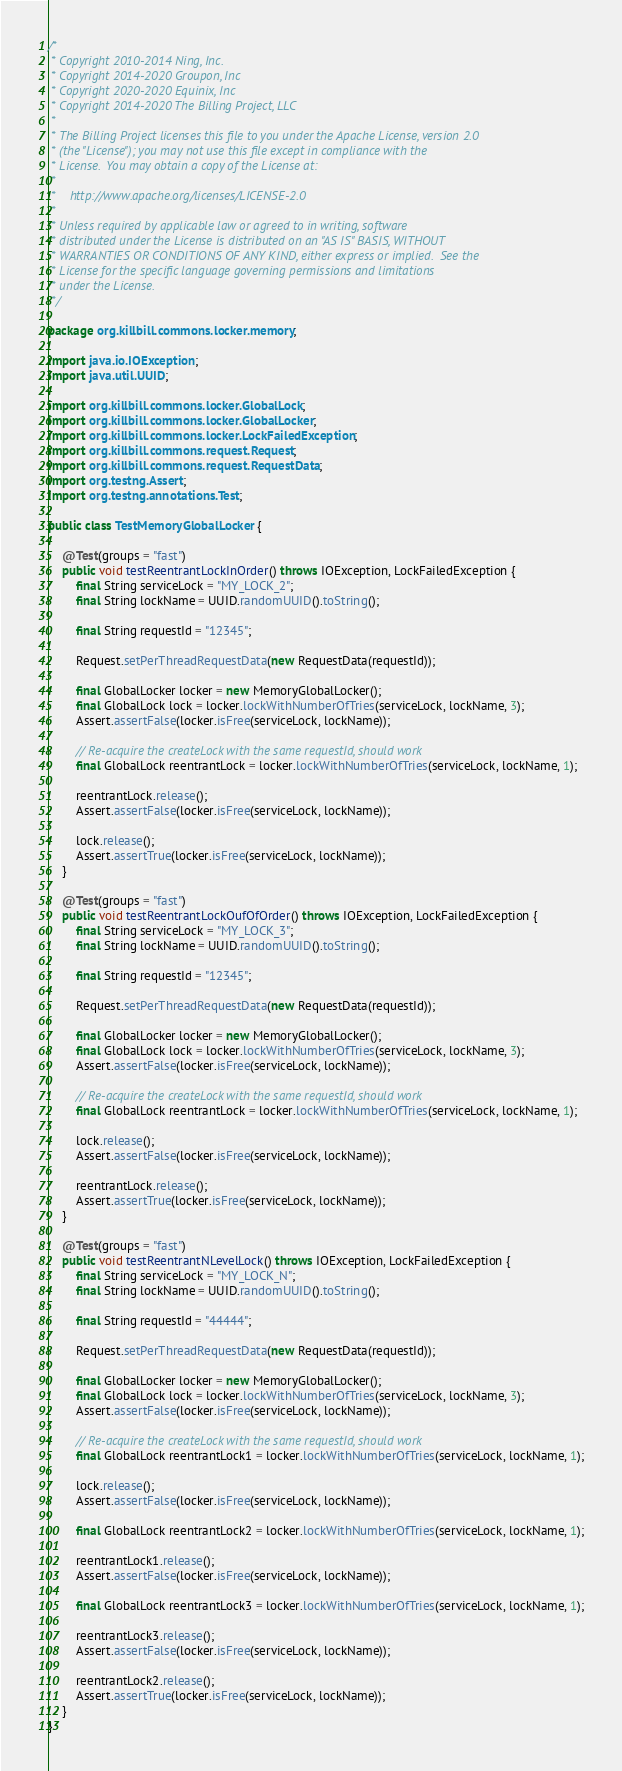<code> <loc_0><loc_0><loc_500><loc_500><_Java_>/*
 * Copyright 2010-2014 Ning, Inc.
 * Copyright 2014-2020 Groupon, Inc
 * Copyright 2020-2020 Equinix, Inc
 * Copyright 2014-2020 The Billing Project, LLC
 *
 * The Billing Project licenses this file to you under the Apache License, version 2.0
 * (the "License"); you may not use this file except in compliance with the
 * License.  You may obtain a copy of the License at:
 *
 *    http://www.apache.org/licenses/LICENSE-2.0
 *
 * Unless required by applicable law or agreed to in writing, software
 * distributed under the License is distributed on an "AS IS" BASIS, WITHOUT
 * WARRANTIES OR CONDITIONS OF ANY KIND, either express or implied.  See the
 * License for the specific language governing permissions and limitations
 * under the License.
 */

package org.killbill.commons.locker.memory;

import java.io.IOException;
import java.util.UUID;

import org.killbill.commons.locker.GlobalLock;
import org.killbill.commons.locker.GlobalLocker;
import org.killbill.commons.locker.LockFailedException;
import org.killbill.commons.request.Request;
import org.killbill.commons.request.RequestData;
import org.testng.Assert;
import org.testng.annotations.Test;

public class TestMemoryGlobalLocker {

    @Test(groups = "fast")
    public void testReentrantLockInOrder() throws IOException, LockFailedException {
        final String serviceLock = "MY_LOCK_2";
        final String lockName = UUID.randomUUID().toString();

        final String requestId = "12345";

        Request.setPerThreadRequestData(new RequestData(requestId));

        final GlobalLocker locker = new MemoryGlobalLocker();
        final GlobalLock lock = locker.lockWithNumberOfTries(serviceLock, lockName, 3);
        Assert.assertFalse(locker.isFree(serviceLock, lockName));

        // Re-acquire the createLock with the same requestId, should work
        final GlobalLock reentrantLock = locker.lockWithNumberOfTries(serviceLock, lockName, 1);

        reentrantLock.release();
        Assert.assertFalse(locker.isFree(serviceLock, lockName));

        lock.release();
        Assert.assertTrue(locker.isFree(serviceLock, lockName));
    }

    @Test(groups = "fast")
    public void testReentrantLockOufOfOrder() throws IOException, LockFailedException {
        final String serviceLock = "MY_LOCK_3";
        final String lockName = UUID.randomUUID().toString();

        final String requestId = "12345";

        Request.setPerThreadRequestData(new RequestData(requestId));

        final GlobalLocker locker = new MemoryGlobalLocker();
        final GlobalLock lock = locker.lockWithNumberOfTries(serviceLock, lockName, 3);
        Assert.assertFalse(locker.isFree(serviceLock, lockName));

        // Re-acquire the createLock with the same requestId, should work
        final GlobalLock reentrantLock = locker.lockWithNumberOfTries(serviceLock, lockName, 1);

        lock.release();
        Assert.assertFalse(locker.isFree(serviceLock, lockName));

        reentrantLock.release();
        Assert.assertTrue(locker.isFree(serviceLock, lockName));
    }

    @Test(groups = "fast")
    public void testReentrantNLevelLock() throws IOException, LockFailedException {
        final String serviceLock = "MY_LOCK_N";
        final String lockName = UUID.randomUUID().toString();

        final String requestId = "44444";

        Request.setPerThreadRequestData(new RequestData(requestId));

        final GlobalLocker locker = new MemoryGlobalLocker();
        final GlobalLock lock = locker.lockWithNumberOfTries(serviceLock, lockName, 3);
        Assert.assertFalse(locker.isFree(serviceLock, lockName));

        // Re-acquire the createLock with the same requestId, should work
        final GlobalLock reentrantLock1 = locker.lockWithNumberOfTries(serviceLock, lockName, 1);

        lock.release();
        Assert.assertFalse(locker.isFree(serviceLock, lockName));

        final GlobalLock reentrantLock2 = locker.lockWithNumberOfTries(serviceLock, lockName, 1);

        reentrantLock1.release();
        Assert.assertFalse(locker.isFree(serviceLock, lockName));

        final GlobalLock reentrantLock3 = locker.lockWithNumberOfTries(serviceLock, lockName, 1);

        reentrantLock3.release();
        Assert.assertFalse(locker.isFree(serviceLock, lockName));

        reentrantLock2.release();
        Assert.assertTrue(locker.isFree(serviceLock, lockName));
    }
}
</code> 